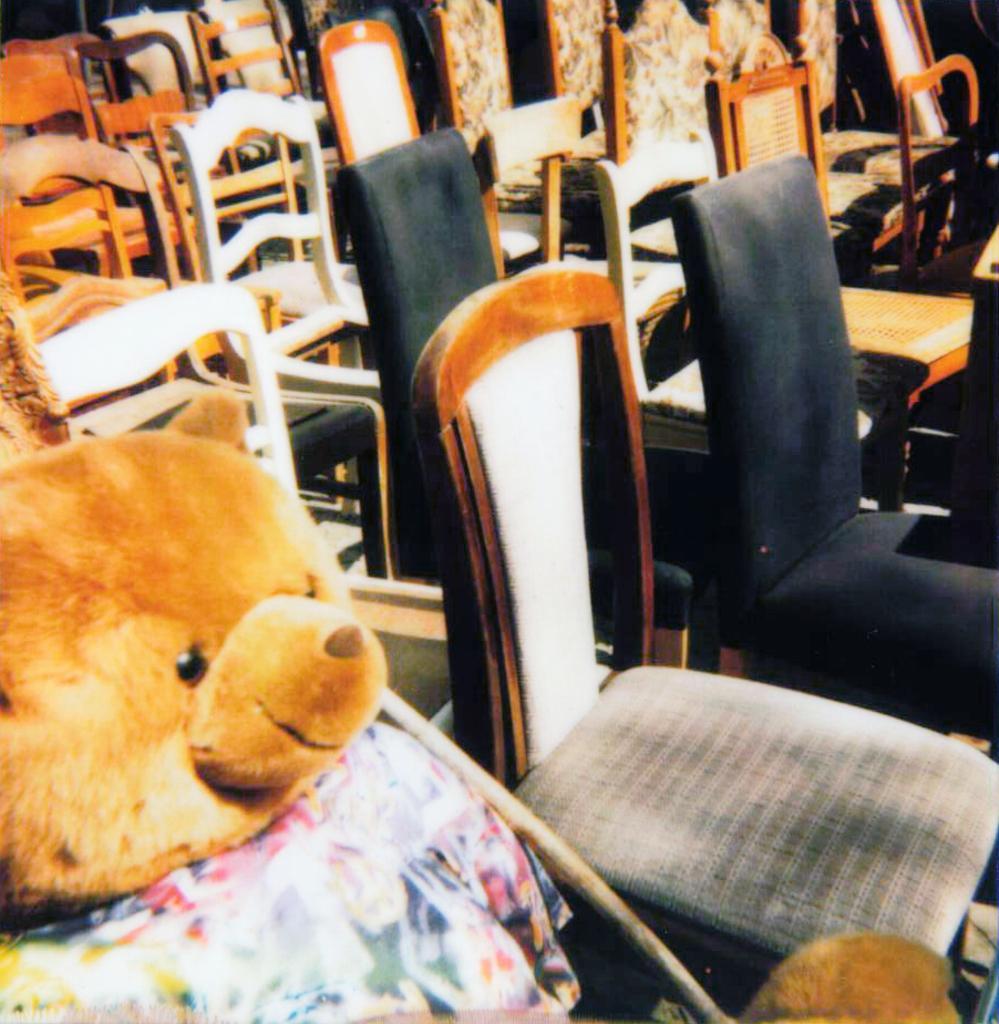Please provide a concise description of this image. there is a soft toy placed on a chair. there are many chairs in a room, which are white, brown and black in color. the toy is a teddy bear which is brown in color. 